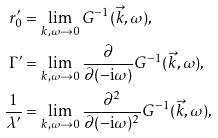Convert formula to latex. <formula><loc_0><loc_0><loc_500><loc_500>r _ { 0 } ^ { \prime } & = \lim _ { k , \omega \to 0 } G ^ { - 1 } ( \vec { k } , \omega ) , \\ \Gamma ^ { \prime } & = \lim _ { k , \omega \to 0 } \frac { \partial } { \partial ( - \text {i} \omega ) } G ^ { - 1 } ( \vec { k } , \omega ) , \\ \frac { 1 } { \lambda ^ { \prime } } & = \lim _ { k , \omega \to 0 } \frac { \partial ^ { 2 } } { \partial ( - \text {i} \omega ) ^ { 2 } } G ^ { - 1 } ( \vec { k } , \omega ) ,</formula> 